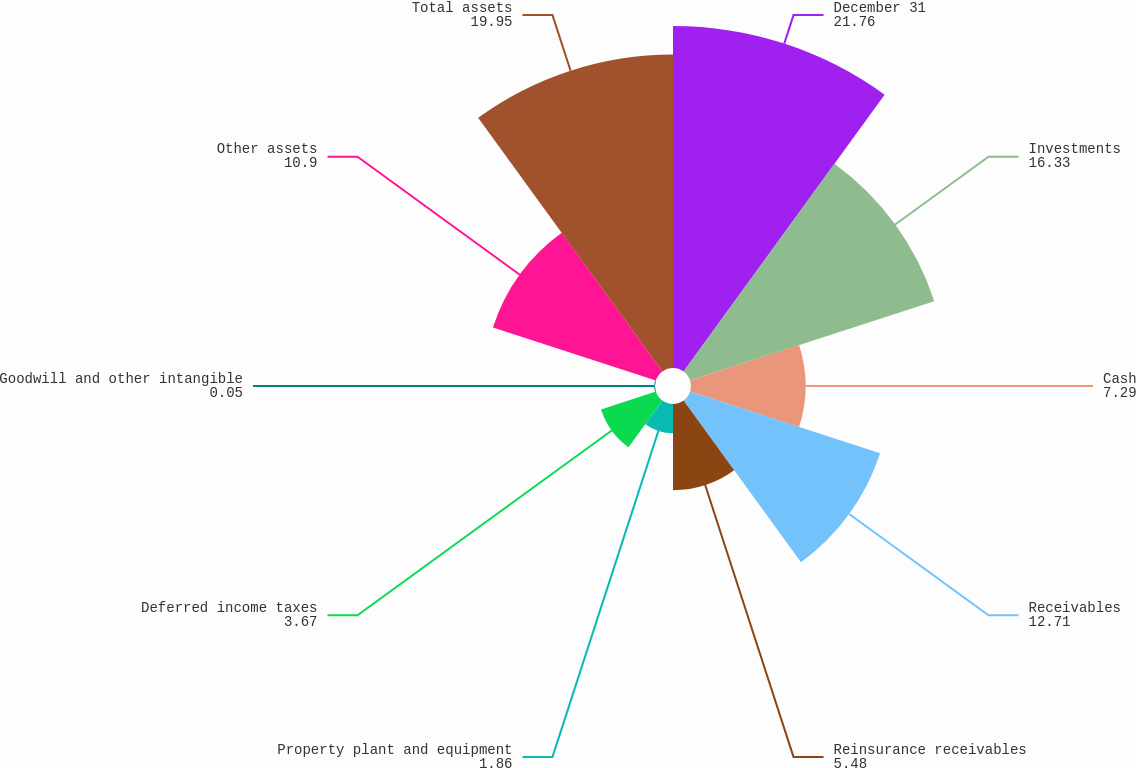Convert chart to OTSL. <chart><loc_0><loc_0><loc_500><loc_500><pie_chart><fcel>December 31<fcel>Investments<fcel>Cash<fcel>Receivables<fcel>Reinsurance receivables<fcel>Property plant and equipment<fcel>Deferred income taxes<fcel>Goodwill and other intangible<fcel>Other assets<fcel>Total assets<nl><fcel>21.76%<fcel>16.33%<fcel>7.29%<fcel>12.71%<fcel>5.48%<fcel>1.86%<fcel>3.67%<fcel>0.05%<fcel>10.9%<fcel>19.95%<nl></chart> 